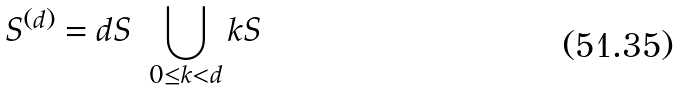<formula> <loc_0><loc_0><loc_500><loc_500>S ^ { ( d ) } = d S \ \bigcup _ { 0 \leq k < d } k S</formula> 